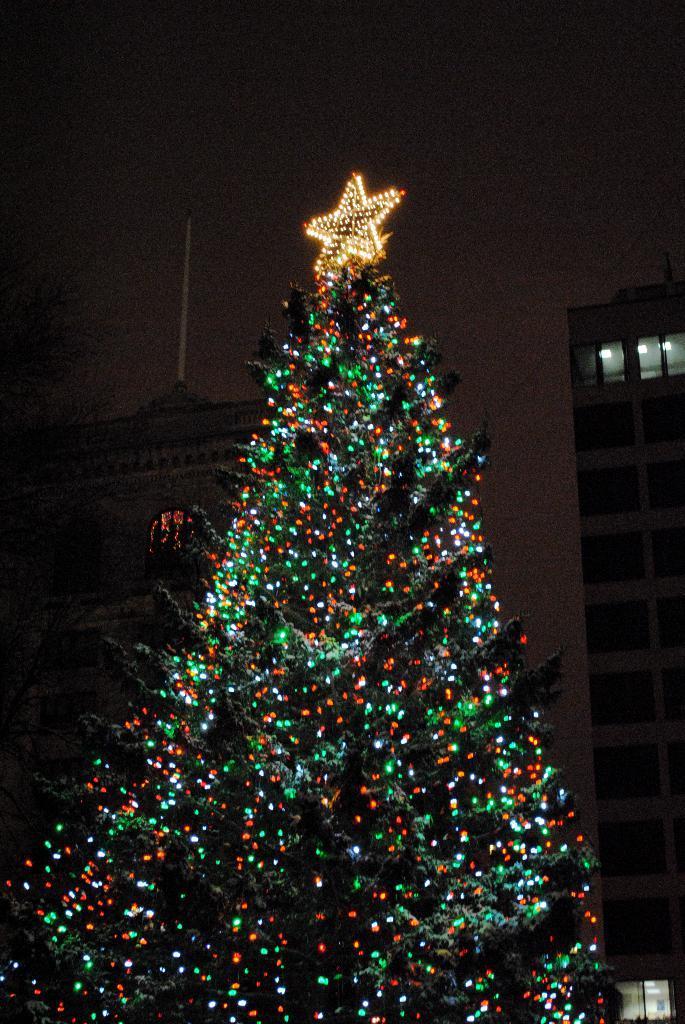How would you summarize this image in a sentence or two? In the image we can see there is a christmas tree which is decorated with lights and there is a star light kept on the christmas tree. Behind there are buildings and the sky is clear. Background of the image is dark. 